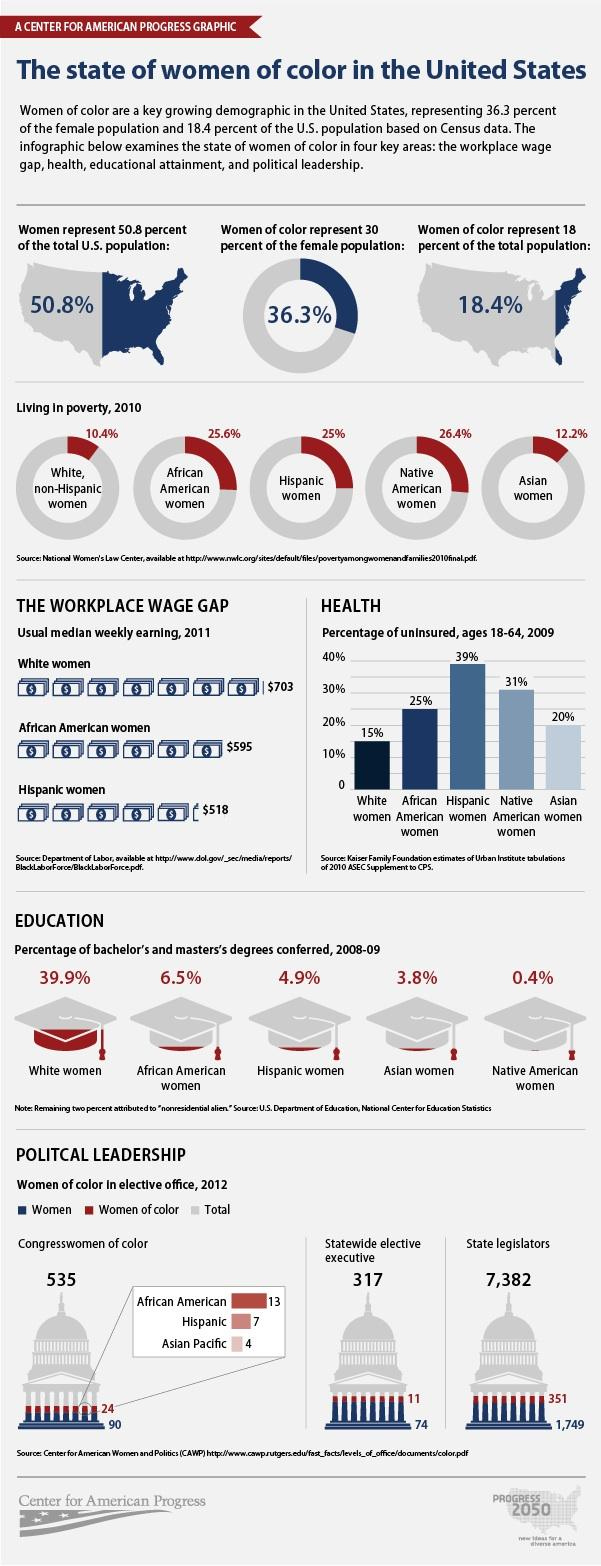Outline some significant characteristics in this image. According to a recent survey, only 0.4% of Native American women holding higher education degrees are teachers. In the year 2012, there were a total of 5,282 men serving as state legislators across the United States. According to the given data, the ethnic group with the second lowest percentage of uninsured women is Asian women. According to recent data, 25.6% of African American women live in poverty. The number of Congresswomen in 2012 was 114. 